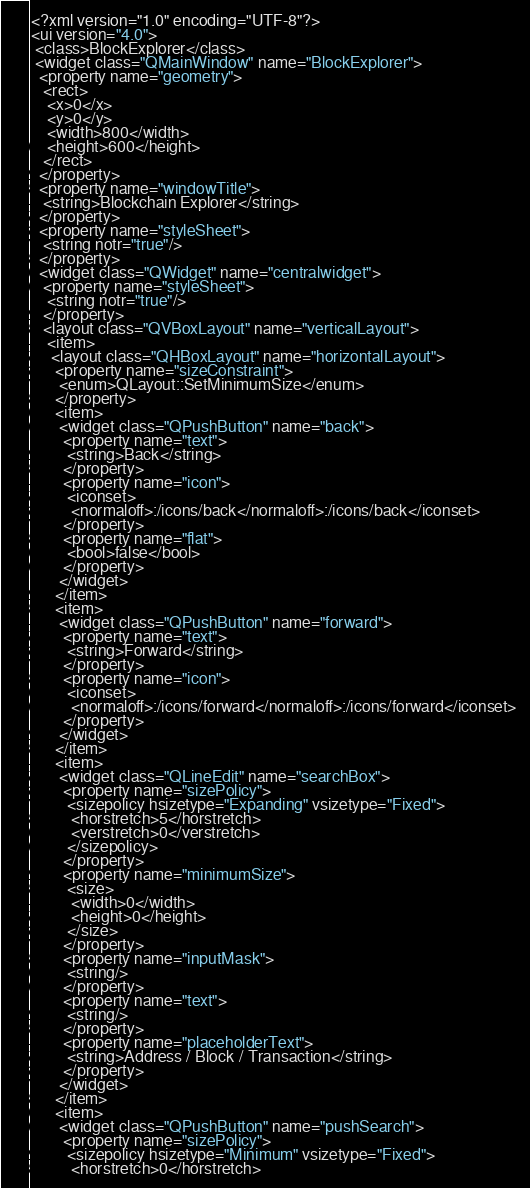Convert code to text. <code><loc_0><loc_0><loc_500><loc_500><_XML_><?xml version="1.0" encoding="UTF-8"?>
<ui version="4.0">
 <class>BlockExplorer</class>
 <widget class="QMainWindow" name="BlockExplorer">
  <property name="geometry">
   <rect>
    <x>0</x>
    <y>0</y>
    <width>800</width>
    <height>600</height>
   </rect>
  </property>
  <property name="windowTitle">
   <string>Blockchain Explorer</string>
  </property>
  <property name="styleSheet">
   <string notr="true"/>
  </property>
  <widget class="QWidget" name="centralwidget">
   <property name="styleSheet">
    <string notr="true"/>
   </property>
   <layout class="QVBoxLayout" name="verticalLayout">
    <item>
     <layout class="QHBoxLayout" name="horizontalLayout">
      <property name="sizeConstraint">
       <enum>QLayout::SetMinimumSize</enum>
      </property>
      <item>
       <widget class="QPushButton" name="back">
        <property name="text">
         <string>Back</string>
        </property>
        <property name="icon">
         <iconset>
          <normaloff>:/icons/back</normaloff>:/icons/back</iconset>
        </property>
        <property name="flat">
         <bool>false</bool>
        </property>
       </widget>
      </item>
      <item>
       <widget class="QPushButton" name="forward">
        <property name="text">
         <string>Forward</string>
        </property>
        <property name="icon">
         <iconset>
          <normaloff>:/icons/forward</normaloff>:/icons/forward</iconset>
        </property>
       </widget>
      </item>
      <item>
       <widget class="QLineEdit" name="searchBox">
        <property name="sizePolicy">
         <sizepolicy hsizetype="Expanding" vsizetype="Fixed">
          <horstretch>5</horstretch>
          <verstretch>0</verstretch>
         </sizepolicy>
        </property>
        <property name="minimumSize">
         <size>
          <width>0</width>
          <height>0</height>
         </size>
        </property>
        <property name="inputMask">
         <string/>
        </property>
        <property name="text">
         <string/>
        </property>
        <property name="placeholderText">
         <string>Address / Block / Transaction</string>
        </property>
       </widget>
      </item>
      <item>
       <widget class="QPushButton" name="pushSearch">
        <property name="sizePolicy">
         <sizepolicy hsizetype="Minimum" vsizetype="Fixed">
          <horstretch>0</horstretch></code> 